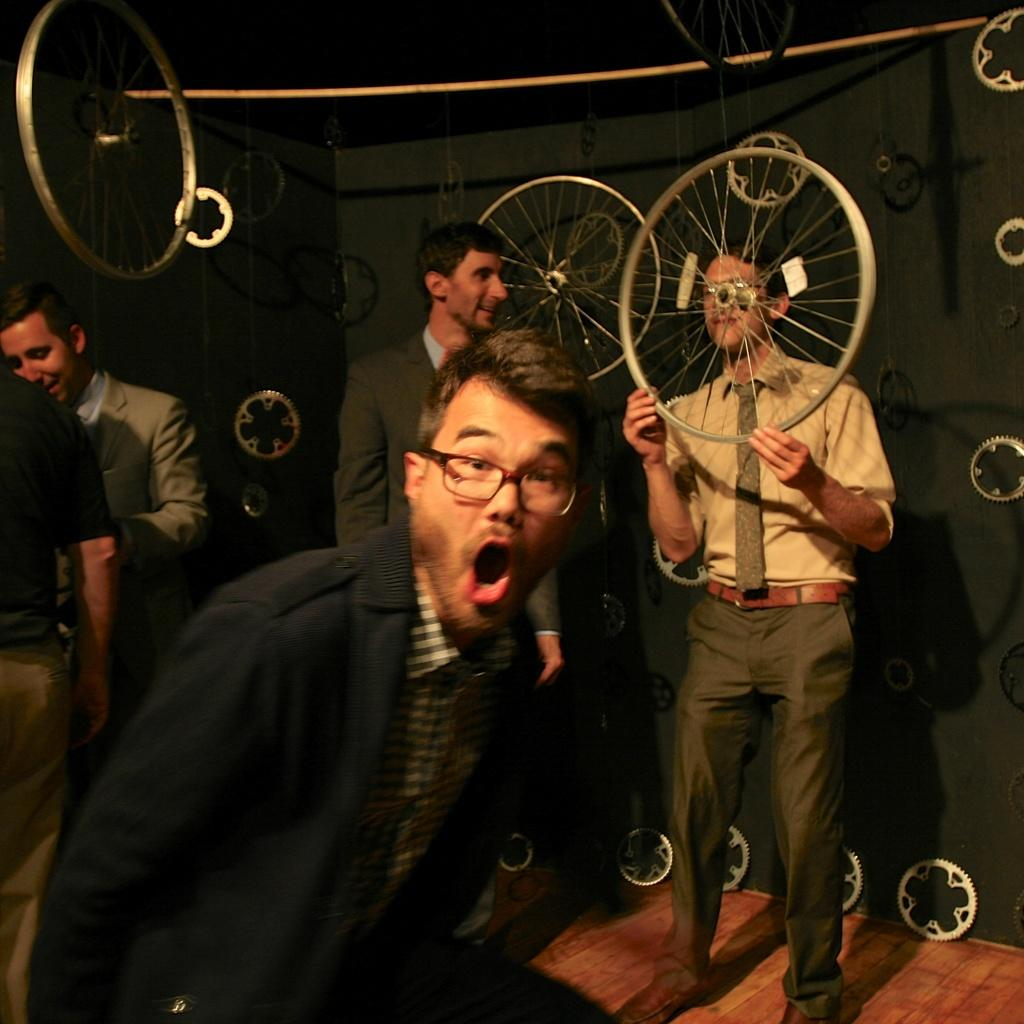How many people are present in the image? There are five persons standing in the image. What can be seen in the background of the image? There are gears and wheels in the background of the image. What is the man on the right side of the image holding? The man on the right side of the image is holding a wheel. Can you hear any songs being sung by the ladybug in the image? There is no ladybug present in the image, and therefore no songs can be heard. What type of environment is depicted in the image, such as a seashore or a forest? The image does not depict a specific environment like a seashore or a forest; it primarily features people and gears/wheels. 